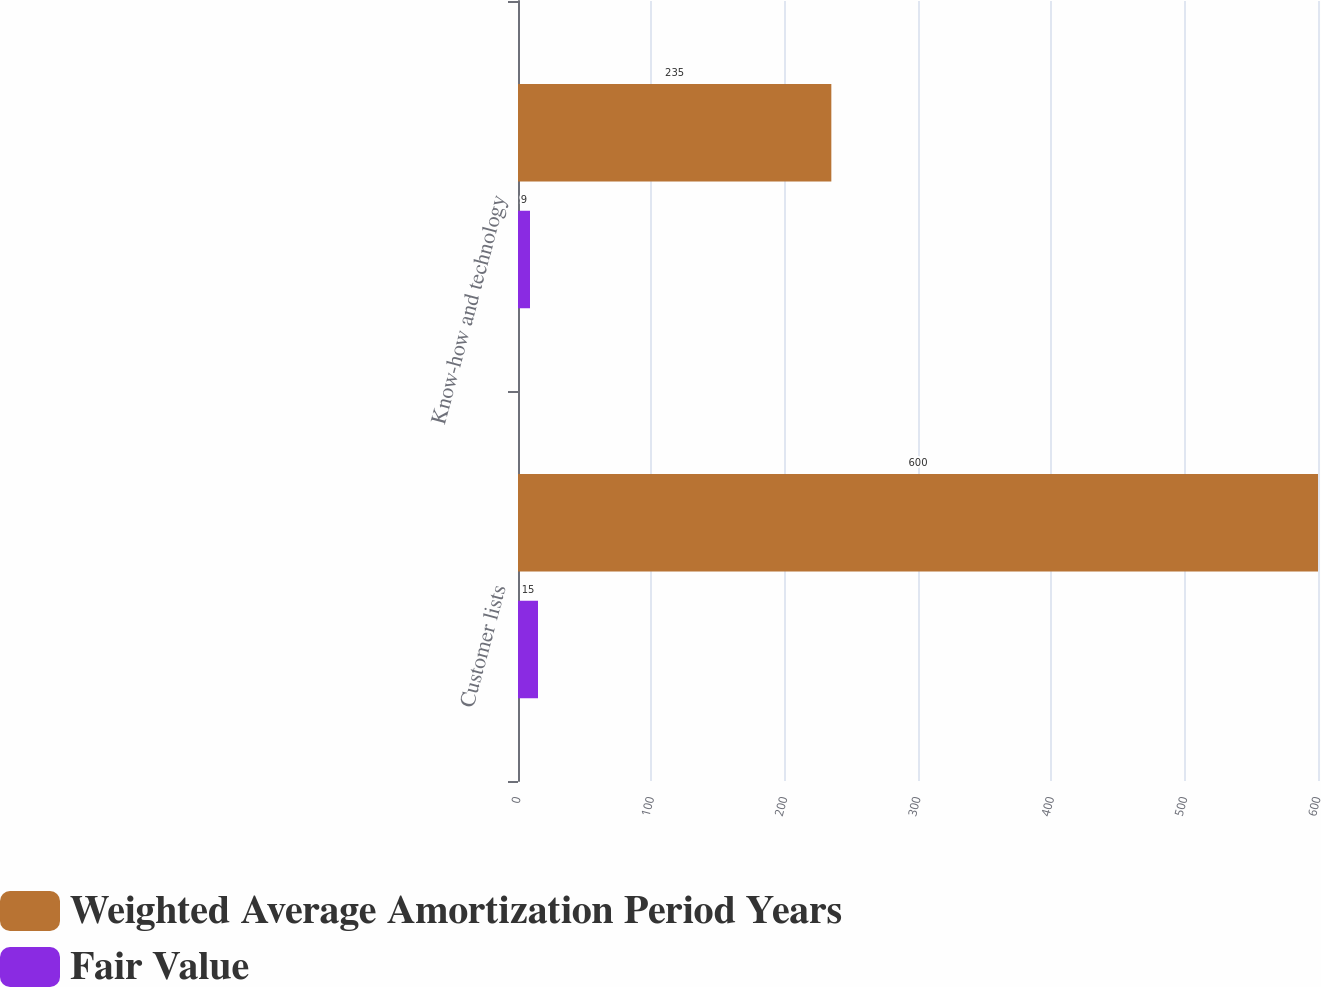Convert chart to OTSL. <chart><loc_0><loc_0><loc_500><loc_500><stacked_bar_chart><ecel><fcel>Customer lists<fcel>Know-how and technology<nl><fcel>Weighted Average Amortization Period Years<fcel>600<fcel>235<nl><fcel>Fair Value<fcel>15<fcel>9<nl></chart> 